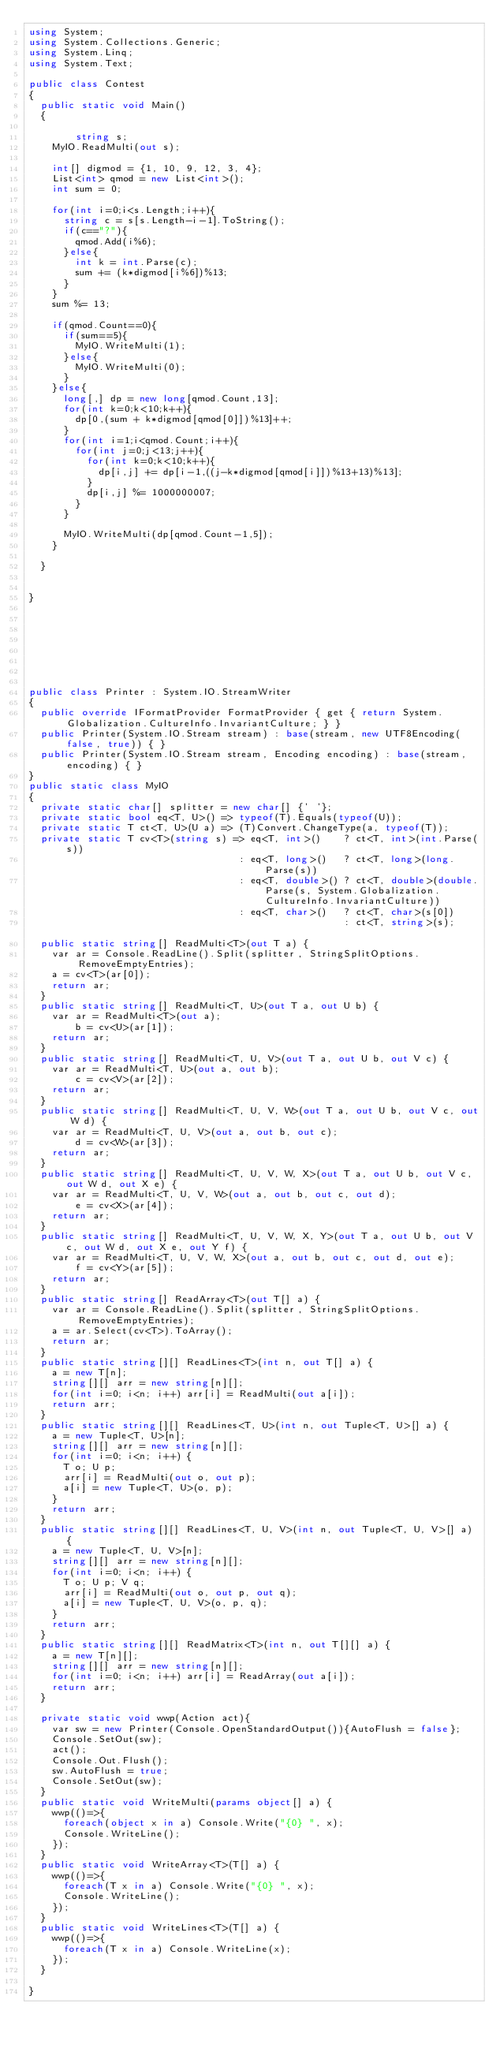Convert code to text. <code><loc_0><loc_0><loc_500><loc_500><_C#_>using System;
using System.Collections.Generic;
using System.Linq;
using System.Text;

public class Contest
{
	public static void Main()
	{

        string s;
		MyIO.ReadMulti(out s);

		int[] digmod = {1, 10, 9, 12, 3, 4};
		List<int> qmod = new List<int>();
		int sum = 0;

		for(int i=0;i<s.Length;i++){
			string c = s[s.Length-i-1].ToString();
			if(c=="?"){
				qmod.Add(i%6);
			}else{
				int k = int.Parse(c);
				sum += (k*digmod[i%6])%13;
			}
		}
		sum %= 13;

		if(qmod.Count==0){
			if(sum==5){
				MyIO.WriteMulti(1);
			}else{
				MyIO.WriteMulti(0);
			}
		}else{
			long[,] dp = new long[qmod.Count,13];
			for(int k=0;k<10;k++){
				dp[0,(sum + k*digmod[qmod[0]])%13]++; 
			}
			for(int i=1;i<qmod.Count;i++){
				for(int j=0;j<13;j++){
					for(int k=0;k<10;k++){
						dp[i,j] += dp[i-1,((j-k*digmod[qmod[i]])%13+13)%13]; 
					}	
					dp[i,j] %= 1000000007;
				}
			}

			MyIO.WriteMulti(dp[qmod.Count-1,5]);
		}

	}


}








public class Printer : System.IO.StreamWriter
{
	public override IFormatProvider FormatProvider { get { return System.Globalization.CultureInfo.InvariantCulture; } }
	public Printer(System.IO.Stream stream) : base(stream, new UTF8Encoding(false, true)) { }
	public Printer(System.IO.Stream stream, Encoding encoding) : base(stream, encoding) { }
}
public static class MyIO
{
	private static char[] splitter = new char[] {' '};
	private static bool eq<T, U>() => typeof(T).Equals(typeof(U));
	private static T ct<T, U>(U a) => (T)Convert.ChangeType(a, typeof(T));
	private static T cv<T>(string s) => eq<T, int>()    ? ct<T, int>(int.Parse(s))
	                                  : eq<T, long>()   ? ct<T, long>(long.Parse(s))
	                                  : eq<T, double>() ? ct<T, double>(double.Parse(s, System.Globalization.CultureInfo.InvariantCulture))
	                                  : eq<T, char>()   ? ct<T, char>(s[0])
	                                                    : ct<T, string>(s);				
	public static string[] ReadMulti<T>(out T a) {
		var ar = Console.ReadLine().Split(splitter, StringSplitOptions.RemoveEmptyEntries); 
		a = cv<T>(ar[0]);
		return ar;
	}
	public static string[] ReadMulti<T, U>(out T a, out U b) {
		var ar = ReadMulti<T>(out a); 
        b = cv<U>(ar[1]);
		return ar;
	}
	public static string[] ReadMulti<T, U, V>(out T a, out U b, out V c) {
		var ar = ReadMulti<T, U>(out a, out b); 
        c = cv<V>(ar[2]);
		return ar;
	}
	public static string[] ReadMulti<T, U, V, W>(out T a, out U b, out V c, out W d) {
		var ar = ReadMulti<T, U, V>(out a, out b, out c); 
        d = cv<W>(ar[3]);
		return ar;
	}
	public static string[] ReadMulti<T, U, V, W, X>(out T a, out U b, out V c, out W d, out X e) {
		var ar = ReadMulti<T, U, V, W>(out a, out b, out c, out d); 
        e = cv<X>(ar[4]);
		return ar;
	}
	public static string[] ReadMulti<T, U, V, W, X, Y>(out T a, out U b, out V c, out W d, out X e, out Y f) {
		var ar = ReadMulti<T, U, V, W, X>(out a, out b, out c, out d, out e); 
        f = cv<Y>(ar[5]);
		return ar;
	}
	public static string[] ReadArray<T>(out T[] a) {		
		var ar = Console.ReadLine().Split(splitter, StringSplitOptions.RemoveEmptyEntries);
		a = ar.Select(cv<T>).ToArray();
		return ar;
	}		
	public static string[][] ReadLines<T>(int n, out T[] a) {
		a = new T[n];
		string[][] arr = new string[n][];
		for(int i=0; i<n; i++) arr[i] = ReadMulti(out a[i]);
		return arr;
	}
	public static string[][] ReadLines<T, U>(int n, out Tuple<T, U>[] a) {
		a = new Tuple<T, U>[n];
		string[][] arr = new string[n][];
		for(int i=0; i<n; i++) {
			T o; U p;
			arr[i] = ReadMulti(out o, out p);
			a[i] = new Tuple<T, U>(o, p);
		}
		return arr;
	}
	public static string[][] ReadLines<T, U, V>(int n, out Tuple<T, U, V>[] a) {
		a = new Tuple<T, U, V>[n];
		string[][] arr = new string[n][];
		for(int i=0; i<n; i++) {
			T o; U p; V q;
			arr[i] = ReadMulti(out o, out p, out q);
			a[i] = new Tuple<T, U, V>(o, p, q);
		}
		return arr;
	}
	public static string[][] ReadMatrix<T>(int n, out T[][] a) {
		a = new T[n][];
		string[][] arr = new string[n][];
		for(int i=0; i<n; i++) arr[i] = ReadArray(out a[i]);
		return arr;
	}

	private static void wwp(Action act){
		var sw = new Printer(Console.OpenStandardOutput()){AutoFlush = false};
		Console.SetOut(sw);
		act();
		Console.Out.Flush();
		sw.AutoFlush = true;
		Console.SetOut(sw);
	}
	public static void WriteMulti(params object[] a) {
		wwp(()=>{
			foreach(object x in a) Console.Write("{0} ", x);
			Console.WriteLine();
		});
	}
	public static void WriteArray<T>(T[] a) {
		wwp(()=>{
			foreach(T x in a) Console.Write("{0} ", x);
			Console.WriteLine();
		});
	}
	public static void WriteLines<T>(T[] a) {
		wwp(()=>{
			foreach(T x in a) Console.WriteLine(x);
		});
	}

}



</code> 